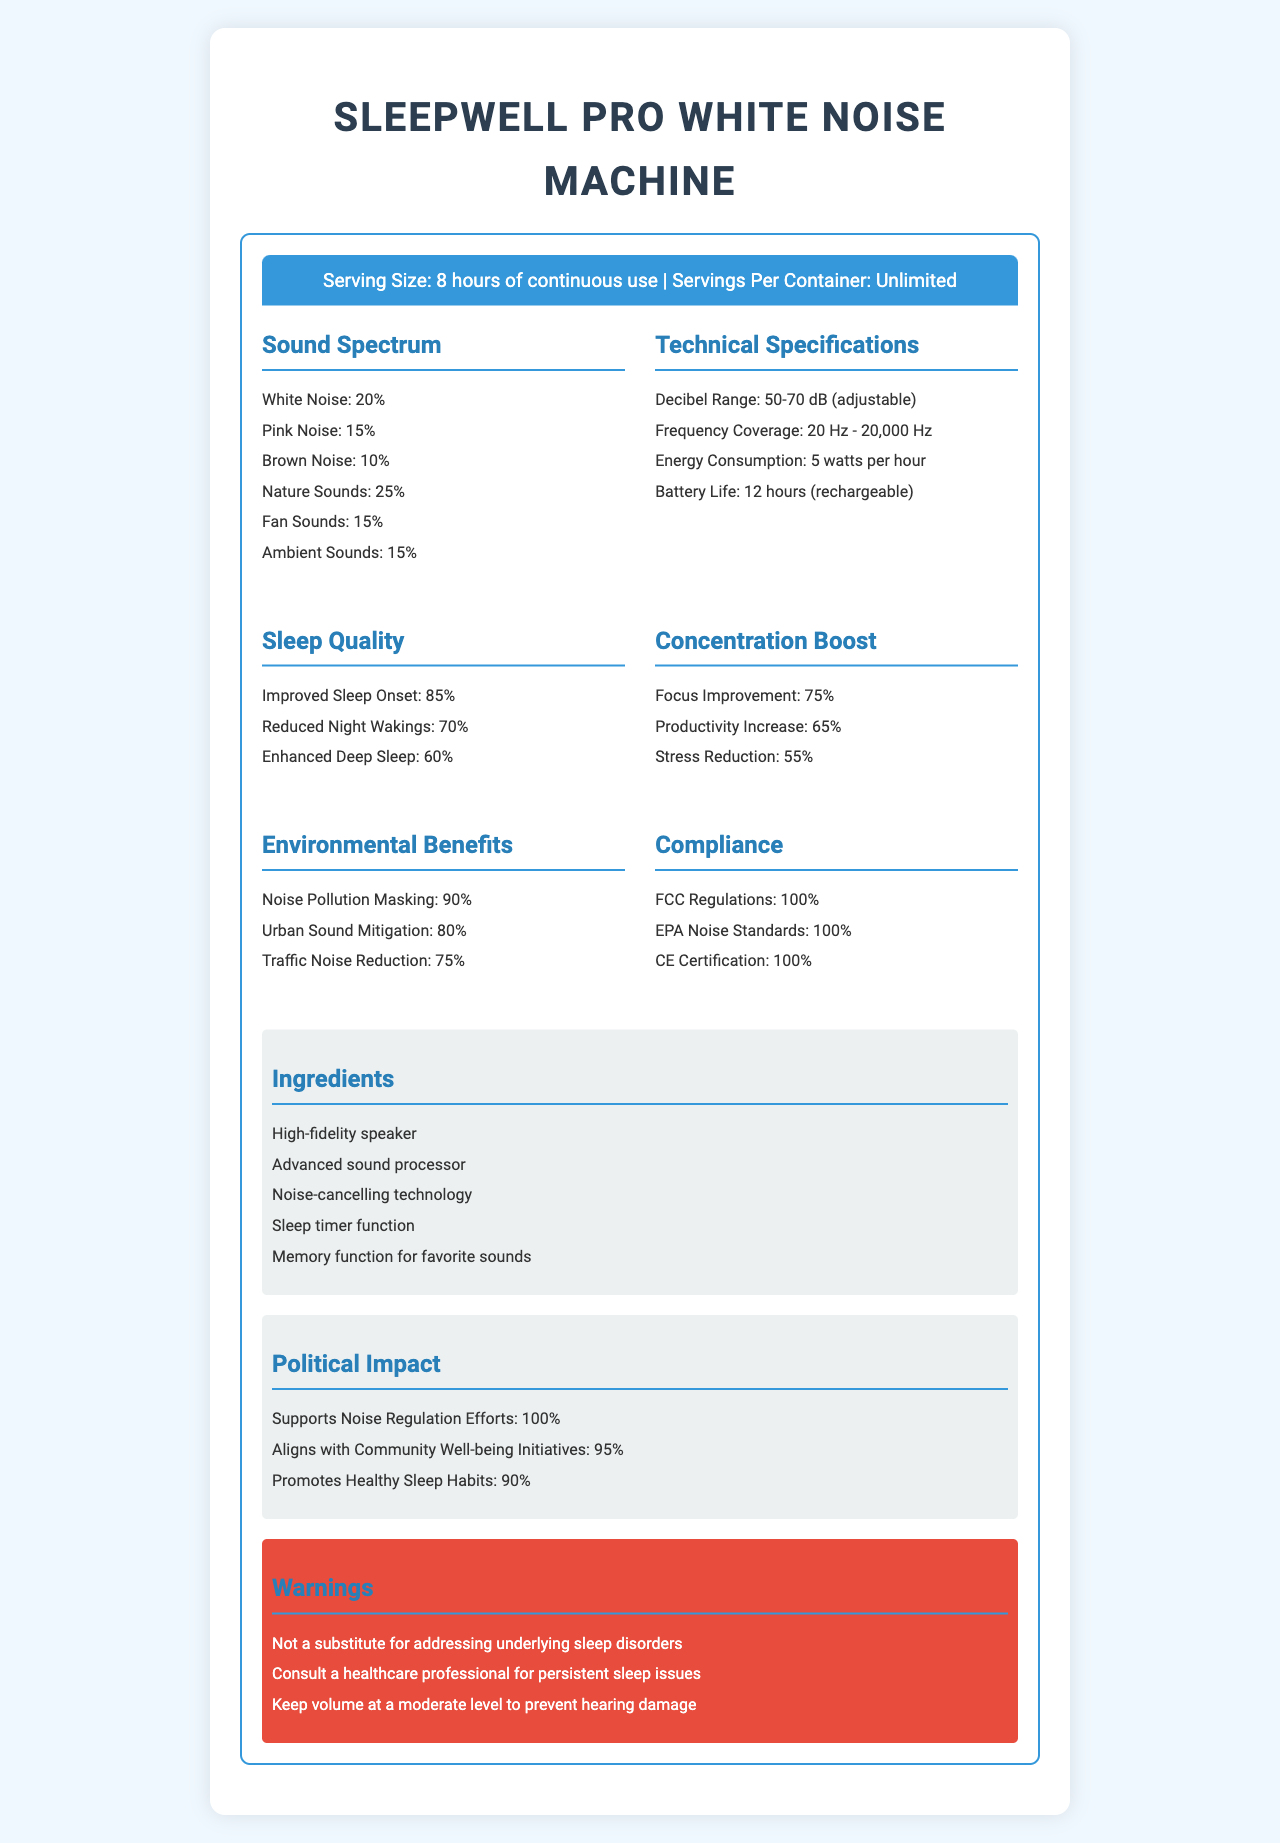what is the serving size for the SleepWell Pro White Noise Machine? The serving size is clearly labeled as "8 hours of continuous use" under the product name section.
Answer: 8 hours of continuous use how much of the sound spectrum is dedicated to nature sounds? In the Sound Spectrum section, nature sounds make up 25% of the sound spectrum.
Answer: 25% what is the decibel range of this machine? The decibel range is listed in the Technical Specifications section as "50-70 dB (adjustable)".
Answer: 50-70 dB (adjustable) what frequency range does the SleepWell Pro White Noise Machine cover? The frequency coverage is specified in the Technical Specifications section as "20 Hz - 20,000 Hz".
Answer: 20 Hz - 20,000 Hz what compliance certifications does the product have? The Compliance section lists the certifications: "FCC Regulations: 100%, EPA Noise Standards: 100%, CE Certification: 100%".
Answer: FCC Regulations, EPA Noise Standards, CE Certification what improvement percentage is associated with reduced night wakings? The Sleep Quality section specifies that reduced night wakings have a 70% improvement.
Answer: 70% which sound type occupies the highest percentage in the sound spectrum? A. White Noise B. Pink Noise C. Nature Sounds D. Fan Sounds The Sound Spectrum section shows that nature sounds occupy the highest percentage at 25%.
Answer: C what is the energy consumption of the SleepWell Pro White Noise Machine per hour? A. 3 watts B. 4 watts C. 5 watts D. 6 watts The Technical Specifications section states that the energy consumption is "5 watts per hour".
Answer: C does the SleepWell Pro White Noise Machine support noise regulation efforts? The Political Impact section states that it supports noise regulation efforts at 100%.
Answer: Yes is the SleepWell Pro White Noise Machine suitable for usage as a substitute for addressing underlying sleep disorders? The Warnings section indicates it is not a substitute for addressing underlying sleep disorders.
Answer: No how does the product aim to benefit the environment? The Environmental Benefits section lists these benefits: "Noise Pollution Masking: 90%, Urban Sound Mitigation: 80%, Traffic Noise Reduction: 75%".
Answer: Noise pollution masking, urban sound mitigation, traffic noise reduction what are the ingredients of the SleepWell Pro White Noise Machine? The Ingredients section lists these components: "High-fidelity speaker, Advanced sound processor, Noise-cancelling technology, Sleep timer function, Memory function for favorite sounds".
Answer: High-fidelity speaker, Advanced sound processor, Noise-cancelling technology, Sleep timer function, Memory function for favorite sounds describe the main purpose and contents of the document The main purpose of the document is to present comprehensive information about the SleepWell Pro White Noise Machine, including its sound capabilities, technical details, and benefits for sleep, concentration, and the environment, along with its compliance with regulations and impact on noise regulation efforts.
Answer: The document provides a detailed overview and nutritional facts label for the SleepWell Pro White Noise Machine, highlighting its features, technical specifications, sound spectrum, sleep quality and concentration benefits, environmental impact, energy consumption, compliance with regulations, ingredients, political impact, and warnings. what is the manufacturing cost of the SleepWell Pro White Noise Machine? The document does not provide any information about the manufacturing cost of the SleepWell Pro White Noise Machine.
Answer: Not enough information 